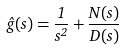<formula> <loc_0><loc_0><loc_500><loc_500>\hat { g } ( s ) = \frac { 1 } { s ^ { 2 } } + \frac { N ( s ) } { D ( s ) }</formula> 